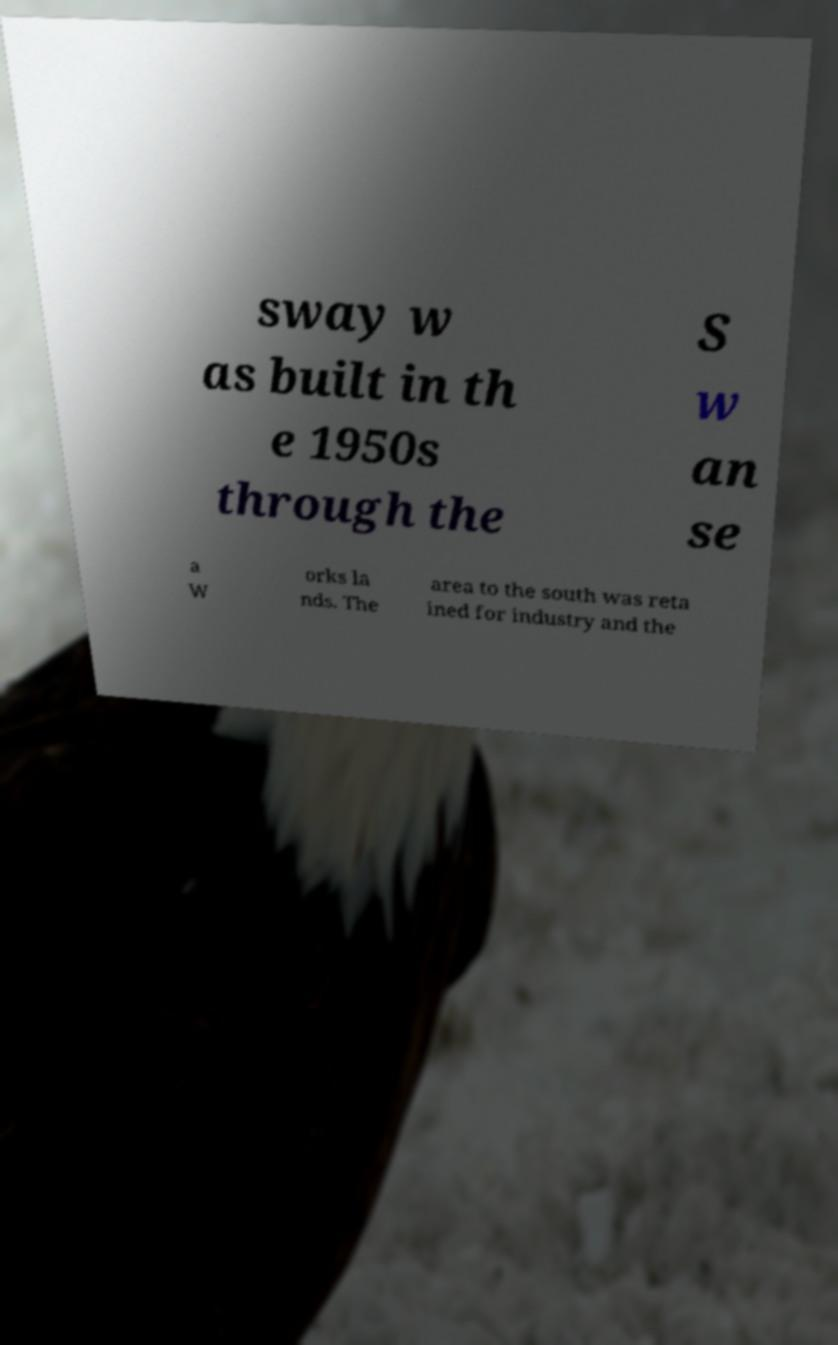I need the written content from this picture converted into text. Can you do that? sway w as built in th e 1950s through the S w an se a W orks la nds. The area to the south was reta ined for industry and the 